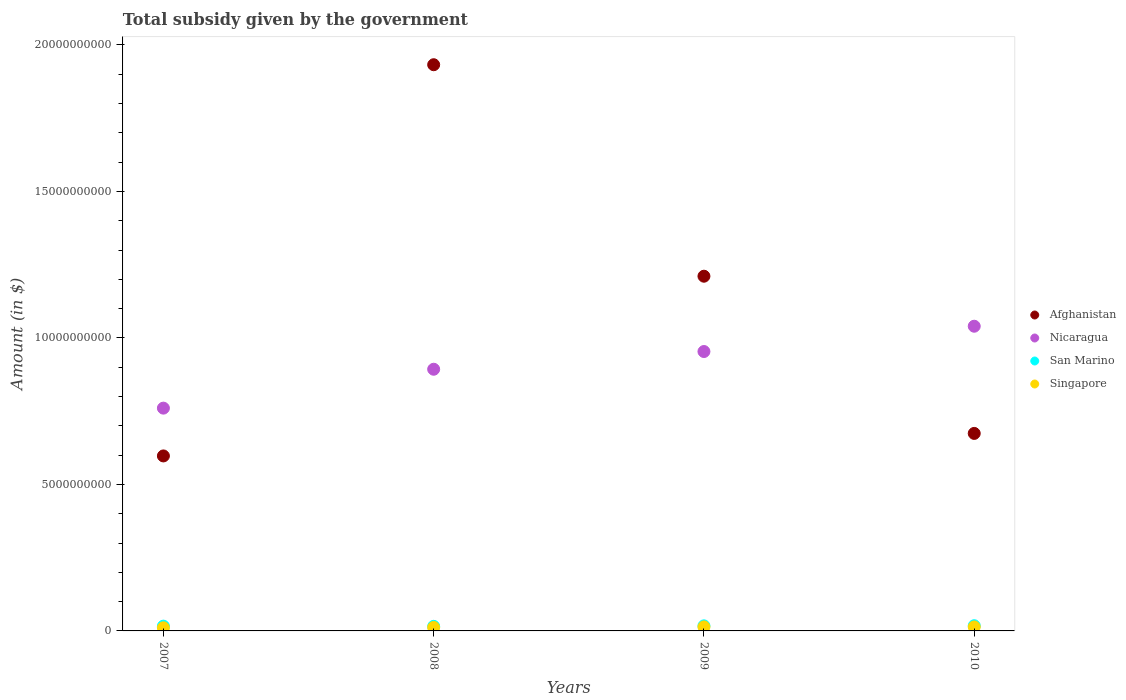Is the number of dotlines equal to the number of legend labels?
Your answer should be compact. Yes. What is the total revenue collected by the government in San Marino in 2008?
Provide a succinct answer. 1.57e+08. Across all years, what is the maximum total revenue collected by the government in Afghanistan?
Provide a short and direct response. 1.93e+1. Across all years, what is the minimum total revenue collected by the government in San Marino?
Make the answer very short. 1.57e+08. What is the total total revenue collected by the government in Nicaragua in the graph?
Keep it short and to the point. 3.65e+1. What is the difference between the total revenue collected by the government in Afghanistan in 2008 and that in 2010?
Provide a short and direct response. 1.26e+1. What is the difference between the total revenue collected by the government in San Marino in 2008 and the total revenue collected by the government in Afghanistan in 2009?
Your answer should be very brief. -1.20e+1. What is the average total revenue collected by the government in Singapore per year?
Ensure brevity in your answer.  1.25e+08. In the year 2009, what is the difference between the total revenue collected by the government in Nicaragua and total revenue collected by the government in Singapore?
Ensure brevity in your answer.  9.40e+09. In how many years, is the total revenue collected by the government in San Marino greater than 1000000000 $?
Ensure brevity in your answer.  0. What is the ratio of the total revenue collected by the government in Afghanistan in 2007 to that in 2009?
Provide a short and direct response. 0.49. Is the total revenue collected by the government in Singapore in 2008 less than that in 2010?
Provide a succinct answer. Yes. Is the difference between the total revenue collected by the government in Nicaragua in 2008 and 2009 greater than the difference between the total revenue collected by the government in Singapore in 2008 and 2009?
Give a very brief answer. No. What is the difference between the highest and the second highest total revenue collected by the government in Singapore?
Your answer should be very brief. 1.30e+06. What is the difference between the highest and the lowest total revenue collected by the government in Afghanistan?
Offer a very short reply. 1.34e+1. In how many years, is the total revenue collected by the government in Afghanistan greater than the average total revenue collected by the government in Afghanistan taken over all years?
Offer a terse response. 2. Is the sum of the total revenue collected by the government in San Marino in 2008 and 2010 greater than the maximum total revenue collected by the government in Nicaragua across all years?
Offer a very short reply. No. Is it the case that in every year, the sum of the total revenue collected by the government in Singapore and total revenue collected by the government in San Marino  is greater than the sum of total revenue collected by the government in Nicaragua and total revenue collected by the government in Afghanistan?
Offer a very short reply. Yes. Is it the case that in every year, the sum of the total revenue collected by the government in Afghanistan and total revenue collected by the government in San Marino  is greater than the total revenue collected by the government in Singapore?
Make the answer very short. Yes. Are the values on the major ticks of Y-axis written in scientific E-notation?
Your answer should be very brief. No. Does the graph contain any zero values?
Your response must be concise. No. How are the legend labels stacked?
Give a very brief answer. Vertical. What is the title of the graph?
Ensure brevity in your answer.  Total subsidy given by the government. Does "Malawi" appear as one of the legend labels in the graph?
Give a very brief answer. No. What is the label or title of the X-axis?
Your answer should be very brief. Years. What is the label or title of the Y-axis?
Offer a very short reply. Amount (in $). What is the Amount (in $) of Afghanistan in 2007?
Offer a very short reply. 5.97e+09. What is the Amount (in $) in Nicaragua in 2007?
Ensure brevity in your answer.  7.60e+09. What is the Amount (in $) of San Marino in 2007?
Offer a terse response. 1.63e+08. What is the Amount (in $) in Singapore in 2007?
Ensure brevity in your answer.  1.07e+08. What is the Amount (in $) of Afghanistan in 2008?
Your response must be concise. 1.93e+1. What is the Amount (in $) of Nicaragua in 2008?
Offer a terse response. 8.93e+09. What is the Amount (in $) in San Marino in 2008?
Your answer should be compact. 1.57e+08. What is the Amount (in $) of Singapore in 2008?
Make the answer very short. 1.19e+08. What is the Amount (in $) in Afghanistan in 2009?
Give a very brief answer. 1.21e+1. What is the Amount (in $) of Nicaragua in 2009?
Offer a very short reply. 9.54e+09. What is the Amount (in $) of San Marino in 2009?
Your response must be concise. 1.73e+08. What is the Amount (in $) in Singapore in 2009?
Ensure brevity in your answer.  1.37e+08. What is the Amount (in $) in Afghanistan in 2010?
Ensure brevity in your answer.  6.74e+09. What is the Amount (in $) in Nicaragua in 2010?
Ensure brevity in your answer.  1.04e+1. What is the Amount (in $) in San Marino in 2010?
Make the answer very short. 1.77e+08. What is the Amount (in $) of Singapore in 2010?
Offer a terse response. 1.36e+08. Across all years, what is the maximum Amount (in $) in Afghanistan?
Offer a terse response. 1.93e+1. Across all years, what is the maximum Amount (in $) in Nicaragua?
Provide a succinct answer. 1.04e+1. Across all years, what is the maximum Amount (in $) of San Marino?
Make the answer very short. 1.77e+08. Across all years, what is the maximum Amount (in $) in Singapore?
Your response must be concise. 1.37e+08. Across all years, what is the minimum Amount (in $) of Afghanistan?
Provide a short and direct response. 5.97e+09. Across all years, what is the minimum Amount (in $) in Nicaragua?
Provide a succinct answer. 7.60e+09. Across all years, what is the minimum Amount (in $) of San Marino?
Keep it short and to the point. 1.57e+08. Across all years, what is the minimum Amount (in $) in Singapore?
Ensure brevity in your answer.  1.07e+08. What is the total Amount (in $) of Afghanistan in the graph?
Your answer should be compact. 4.41e+1. What is the total Amount (in $) of Nicaragua in the graph?
Your answer should be very brief. 3.65e+1. What is the total Amount (in $) of San Marino in the graph?
Give a very brief answer. 6.70e+08. What is the total Amount (in $) of Singapore in the graph?
Provide a short and direct response. 4.99e+08. What is the difference between the Amount (in $) in Afghanistan in 2007 and that in 2008?
Make the answer very short. -1.34e+1. What is the difference between the Amount (in $) in Nicaragua in 2007 and that in 2008?
Ensure brevity in your answer.  -1.33e+09. What is the difference between the Amount (in $) of San Marino in 2007 and that in 2008?
Your answer should be very brief. 6.40e+06. What is the difference between the Amount (in $) of Singapore in 2007 and that in 2008?
Provide a succinct answer. -1.20e+07. What is the difference between the Amount (in $) in Afghanistan in 2007 and that in 2009?
Your answer should be compact. -6.13e+09. What is the difference between the Amount (in $) of Nicaragua in 2007 and that in 2009?
Provide a short and direct response. -1.93e+09. What is the difference between the Amount (in $) of San Marino in 2007 and that in 2009?
Your answer should be compact. -9.95e+06. What is the difference between the Amount (in $) in Singapore in 2007 and that in 2009?
Your response must be concise. -3.00e+07. What is the difference between the Amount (in $) of Afghanistan in 2007 and that in 2010?
Make the answer very short. -7.68e+08. What is the difference between the Amount (in $) in Nicaragua in 2007 and that in 2010?
Provide a succinct answer. -2.80e+09. What is the difference between the Amount (in $) of San Marino in 2007 and that in 2010?
Ensure brevity in your answer.  -1.44e+07. What is the difference between the Amount (in $) in Singapore in 2007 and that in 2010?
Offer a very short reply. -2.87e+07. What is the difference between the Amount (in $) of Afghanistan in 2008 and that in 2009?
Ensure brevity in your answer.  7.22e+09. What is the difference between the Amount (in $) of Nicaragua in 2008 and that in 2009?
Offer a very short reply. -6.05e+08. What is the difference between the Amount (in $) of San Marino in 2008 and that in 2009?
Your answer should be very brief. -1.64e+07. What is the difference between the Amount (in $) of Singapore in 2008 and that in 2009?
Your response must be concise. -1.80e+07. What is the difference between the Amount (in $) of Afghanistan in 2008 and that in 2010?
Your response must be concise. 1.26e+1. What is the difference between the Amount (in $) of Nicaragua in 2008 and that in 2010?
Provide a short and direct response. -1.47e+09. What is the difference between the Amount (in $) in San Marino in 2008 and that in 2010?
Keep it short and to the point. -2.08e+07. What is the difference between the Amount (in $) of Singapore in 2008 and that in 2010?
Ensure brevity in your answer.  -1.67e+07. What is the difference between the Amount (in $) in Afghanistan in 2009 and that in 2010?
Ensure brevity in your answer.  5.37e+09. What is the difference between the Amount (in $) in Nicaragua in 2009 and that in 2010?
Give a very brief answer. -8.63e+08. What is the difference between the Amount (in $) in San Marino in 2009 and that in 2010?
Keep it short and to the point. -4.45e+06. What is the difference between the Amount (in $) of Singapore in 2009 and that in 2010?
Keep it short and to the point. 1.30e+06. What is the difference between the Amount (in $) of Afghanistan in 2007 and the Amount (in $) of Nicaragua in 2008?
Offer a very short reply. -2.96e+09. What is the difference between the Amount (in $) of Afghanistan in 2007 and the Amount (in $) of San Marino in 2008?
Provide a short and direct response. 5.82e+09. What is the difference between the Amount (in $) in Afghanistan in 2007 and the Amount (in $) in Singapore in 2008?
Offer a very short reply. 5.85e+09. What is the difference between the Amount (in $) in Nicaragua in 2007 and the Amount (in $) in San Marino in 2008?
Keep it short and to the point. 7.45e+09. What is the difference between the Amount (in $) of Nicaragua in 2007 and the Amount (in $) of Singapore in 2008?
Ensure brevity in your answer.  7.48e+09. What is the difference between the Amount (in $) in San Marino in 2007 and the Amount (in $) in Singapore in 2008?
Offer a terse response. 4.40e+07. What is the difference between the Amount (in $) of Afghanistan in 2007 and the Amount (in $) of Nicaragua in 2009?
Make the answer very short. -3.56e+09. What is the difference between the Amount (in $) in Afghanistan in 2007 and the Amount (in $) in San Marino in 2009?
Make the answer very short. 5.80e+09. What is the difference between the Amount (in $) of Afghanistan in 2007 and the Amount (in $) of Singapore in 2009?
Provide a succinct answer. 5.84e+09. What is the difference between the Amount (in $) of Nicaragua in 2007 and the Amount (in $) of San Marino in 2009?
Your answer should be very brief. 7.43e+09. What is the difference between the Amount (in $) of Nicaragua in 2007 and the Amount (in $) of Singapore in 2009?
Provide a short and direct response. 7.47e+09. What is the difference between the Amount (in $) in San Marino in 2007 and the Amount (in $) in Singapore in 2009?
Your answer should be very brief. 2.60e+07. What is the difference between the Amount (in $) of Afghanistan in 2007 and the Amount (in $) of Nicaragua in 2010?
Offer a very short reply. -4.43e+09. What is the difference between the Amount (in $) of Afghanistan in 2007 and the Amount (in $) of San Marino in 2010?
Make the answer very short. 5.80e+09. What is the difference between the Amount (in $) of Afghanistan in 2007 and the Amount (in $) of Singapore in 2010?
Ensure brevity in your answer.  5.84e+09. What is the difference between the Amount (in $) of Nicaragua in 2007 and the Amount (in $) of San Marino in 2010?
Offer a very short reply. 7.43e+09. What is the difference between the Amount (in $) in Nicaragua in 2007 and the Amount (in $) in Singapore in 2010?
Your answer should be compact. 7.47e+09. What is the difference between the Amount (in $) in San Marino in 2007 and the Amount (in $) in Singapore in 2010?
Offer a very short reply. 2.73e+07. What is the difference between the Amount (in $) of Afghanistan in 2008 and the Amount (in $) of Nicaragua in 2009?
Give a very brief answer. 9.79e+09. What is the difference between the Amount (in $) in Afghanistan in 2008 and the Amount (in $) in San Marino in 2009?
Ensure brevity in your answer.  1.92e+1. What is the difference between the Amount (in $) in Afghanistan in 2008 and the Amount (in $) in Singapore in 2009?
Provide a succinct answer. 1.92e+1. What is the difference between the Amount (in $) in Nicaragua in 2008 and the Amount (in $) in San Marino in 2009?
Your response must be concise. 8.76e+09. What is the difference between the Amount (in $) of Nicaragua in 2008 and the Amount (in $) of Singapore in 2009?
Give a very brief answer. 8.79e+09. What is the difference between the Amount (in $) in San Marino in 2008 and the Amount (in $) in Singapore in 2009?
Offer a very short reply. 1.95e+07. What is the difference between the Amount (in $) of Afghanistan in 2008 and the Amount (in $) of Nicaragua in 2010?
Keep it short and to the point. 8.93e+09. What is the difference between the Amount (in $) in Afghanistan in 2008 and the Amount (in $) in San Marino in 2010?
Offer a terse response. 1.91e+1. What is the difference between the Amount (in $) of Afghanistan in 2008 and the Amount (in $) of Singapore in 2010?
Your answer should be compact. 1.92e+1. What is the difference between the Amount (in $) of Nicaragua in 2008 and the Amount (in $) of San Marino in 2010?
Offer a terse response. 8.75e+09. What is the difference between the Amount (in $) in Nicaragua in 2008 and the Amount (in $) in Singapore in 2010?
Keep it short and to the point. 8.80e+09. What is the difference between the Amount (in $) in San Marino in 2008 and the Amount (in $) in Singapore in 2010?
Offer a very short reply. 2.08e+07. What is the difference between the Amount (in $) of Afghanistan in 2009 and the Amount (in $) of Nicaragua in 2010?
Provide a short and direct response. 1.71e+09. What is the difference between the Amount (in $) of Afghanistan in 2009 and the Amount (in $) of San Marino in 2010?
Keep it short and to the point. 1.19e+1. What is the difference between the Amount (in $) in Afghanistan in 2009 and the Amount (in $) in Singapore in 2010?
Give a very brief answer. 1.20e+1. What is the difference between the Amount (in $) of Nicaragua in 2009 and the Amount (in $) of San Marino in 2010?
Provide a succinct answer. 9.36e+09. What is the difference between the Amount (in $) in Nicaragua in 2009 and the Amount (in $) in Singapore in 2010?
Your answer should be very brief. 9.40e+09. What is the difference between the Amount (in $) in San Marino in 2009 and the Amount (in $) in Singapore in 2010?
Your response must be concise. 3.72e+07. What is the average Amount (in $) of Afghanistan per year?
Provide a short and direct response. 1.10e+1. What is the average Amount (in $) in Nicaragua per year?
Provide a succinct answer. 9.12e+09. What is the average Amount (in $) of San Marino per year?
Keep it short and to the point. 1.67e+08. What is the average Amount (in $) of Singapore per year?
Make the answer very short. 1.25e+08. In the year 2007, what is the difference between the Amount (in $) in Afghanistan and Amount (in $) in Nicaragua?
Your answer should be compact. -1.63e+09. In the year 2007, what is the difference between the Amount (in $) in Afghanistan and Amount (in $) in San Marino?
Provide a short and direct response. 5.81e+09. In the year 2007, what is the difference between the Amount (in $) of Afghanistan and Amount (in $) of Singapore?
Offer a very short reply. 5.87e+09. In the year 2007, what is the difference between the Amount (in $) in Nicaragua and Amount (in $) in San Marino?
Offer a terse response. 7.44e+09. In the year 2007, what is the difference between the Amount (in $) in Nicaragua and Amount (in $) in Singapore?
Your answer should be very brief. 7.50e+09. In the year 2007, what is the difference between the Amount (in $) in San Marino and Amount (in $) in Singapore?
Your answer should be compact. 5.60e+07. In the year 2008, what is the difference between the Amount (in $) of Afghanistan and Amount (in $) of Nicaragua?
Your answer should be compact. 1.04e+1. In the year 2008, what is the difference between the Amount (in $) of Afghanistan and Amount (in $) of San Marino?
Your answer should be very brief. 1.92e+1. In the year 2008, what is the difference between the Amount (in $) in Afghanistan and Amount (in $) in Singapore?
Offer a very short reply. 1.92e+1. In the year 2008, what is the difference between the Amount (in $) in Nicaragua and Amount (in $) in San Marino?
Provide a succinct answer. 8.77e+09. In the year 2008, what is the difference between the Amount (in $) in Nicaragua and Amount (in $) in Singapore?
Make the answer very short. 8.81e+09. In the year 2008, what is the difference between the Amount (in $) of San Marino and Amount (in $) of Singapore?
Offer a terse response. 3.75e+07. In the year 2009, what is the difference between the Amount (in $) of Afghanistan and Amount (in $) of Nicaragua?
Your response must be concise. 2.57e+09. In the year 2009, what is the difference between the Amount (in $) of Afghanistan and Amount (in $) of San Marino?
Ensure brevity in your answer.  1.19e+1. In the year 2009, what is the difference between the Amount (in $) in Afghanistan and Amount (in $) in Singapore?
Your answer should be very brief. 1.20e+1. In the year 2009, what is the difference between the Amount (in $) in Nicaragua and Amount (in $) in San Marino?
Ensure brevity in your answer.  9.36e+09. In the year 2009, what is the difference between the Amount (in $) of Nicaragua and Amount (in $) of Singapore?
Your answer should be compact. 9.40e+09. In the year 2009, what is the difference between the Amount (in $) of San Marino and Amount (in $) of Singapore?
Give a very brief answer. 3.59e+07. In the year 2010, what is the difference between the Amount (in $) of Afghanistan and Amount (in $) of Nicaragua?
Provide a short and direct response. -3.66e+09. In the year 2010, what is the difference between the Amount (in $) in Afghanistan and Amount (in $) in San Marino?
Your response must be concise. 6.56e+09. In the year 2010, what is the difference between the Amount (in $) of Afghanistan and Amount (in $) of Singapore?
Provide a short and direct response. 6.61e+09. In the year 2010, what is the difference between the Amount (in $) in Nicaragua and Amount (in $) in San Marino?
Your answer should be compact. 1.02e+1. In the year 2010, what is the difference between the Amount (in $) of Nicaragua and Amount (in $) of Singapore?
Your answer should be very brief. 1.03e+1. In the year 2010, what is the difference between the Amount (in $) in San Marino and Amount (in $) in Singapore?
Keep it short and to the point. 4.17e+07. What is the ratio of the Amount (in $) of Afghanistan in 2007 to that in 2008?
Ensure brevity in your answer.  0.31. What is the ratio of the Amount (in $) in Nicaragua in 2007 to that in 2008?
Your answer should be very brief. 0.85. What is the ratio of the Amount (in $) in San Marino in 2007 to that in 2008?
Give a very brief answer. 1.04. What is the ratio of the Amount (in $) in Singapore in 2007 to that in 2008?
Offer a terse response. 0.9. What is the ratio of the Amount (in $) of Afghanistan in 2007 to that in 2009?
Provide a short and direct response. 0.49. What is the ratio of the Amount (in $) of Nicaragua in 2007 to that in 2009?
Ensure brevity in your answer.  0.8. What is the ratio of the Amount (in $) in San Marino in 2007 to that in 2009?
Your answer should be compact. 0.94. What is the ratio of the Amount (in $) of Singapore in 2007 to that in 2009?
Ensure brevity in your answer.  0.78. What is the ratio of the Amount (in $) of Afghanistan in 2007 to that in 2010?
Provide a short and direct response. 0.89. What is the ratio of the Amount (in $) in Nicaragua in 2007 to that in 2010?
Provide a short and direct response. 0.73. What is the ratio of the Amount (in $) of San Marino in 2007 to that in 2010?
Give a very brief answer. 0.92. What is the ratio of the Amount (in $) of Singapore in 2007 to that in 2010?
Offer a terse response. 0.79. What is the ratio of the Amount (in $) of Afghanistan in 2008 to that in 2009?
Make the answer very short. 1.6. What is the ratio of the Amount (in $) of Nicaragua in 2008 to that in 2009?
Give a very brief answer. 0.94. What is the ratio of the Amount (in $) of San Marino in 2008 to that in 2009?
Your answer should be very brief. 0.91. What is the ratio of the Amount (in $) of Singapore in 2008 to that in 2009?
Provide a succinct answer. 0.87. What is the ratio of the Amount (in $) of Afghanistan in 2008 to that in 2010?
Provide a succinct answer. 2.87. What is the ratio of the Amount (in $) of Nicaragua in 2008 to that in 2010?
Keep it short and to the point. 0.86. What is the ratio of the Amount (in $) in San Marino in 2008 to that in 2010?
Your response must be concise. 0.88. What is the ratio of the Amount (in $) in Singapore in 2008 to that in 2010?
Your answer should be compact. 0.88. What is the ratio of the Amount (in $) of Afghanistan in 2009 to that in 2010?
Keep it short and to the point. 1.8. What is the ratio of the Amount (in $) of Nicaragua in 2009 to that in 2010?
Provide a succinct answer. 0.92. What is the ratio of the Amount (in $) in San Marino in 2009 to that in 2010?
Your answer should be compact. 0.97. What is the ratio of the Amount (in $) in Singapore in 2009 to that in 2010?
Offer a very short reply. 1.01. What is the difference between the highest and the second highest Amount (in $) in Afghanistan?
Give a very brief answer. 7.22e+09. What is the difference between the highest and the second highest Amount (in $) in Nicaragua?
Your answer should be compact. 8.63e+08. What is the difference between the highest and the second highest Amount (in $) of San Marino?
Provide a succinct answer. 4.45e+06. What is the difference between the highest and the second highest Amount (in $) in Singapore?
Make the answer very short. 1.30e+06. What is the difference between the highest and the lowest Amount (in $) of Afghanistan?
Give a very brief answer. 1.34e+1. What is the difference between the highest and the lowest Amount (in $) of Nicaragua?
Ensure brevity in your answer.  2.80e+09. What is the difference between the highest and the lowest Amount (in $) in San Marino?
Your answer should be compact. 2.08e+07. What is the difference between the highest and the lowest Amount (in $) in Singapore?
Keep it short and to the point. 3.00e+07. 